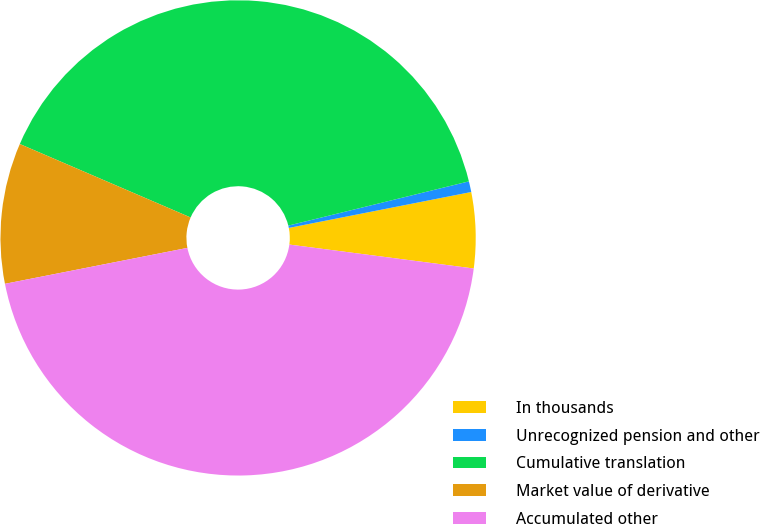Convert chart. <chart><loc_0><loc_0><loc_500><loc_500><pie_chart><fcel>In thousands<fcel>Unrecognized pension and other<fcel>Cumulative translation<fcel>Market value of derivative<fcel>Accumulated other<nl><fcel>5.15%<fcel>0.73%<fcel>39.71%<fcel>9.56%<fcel>44.85%<nl></chart> 